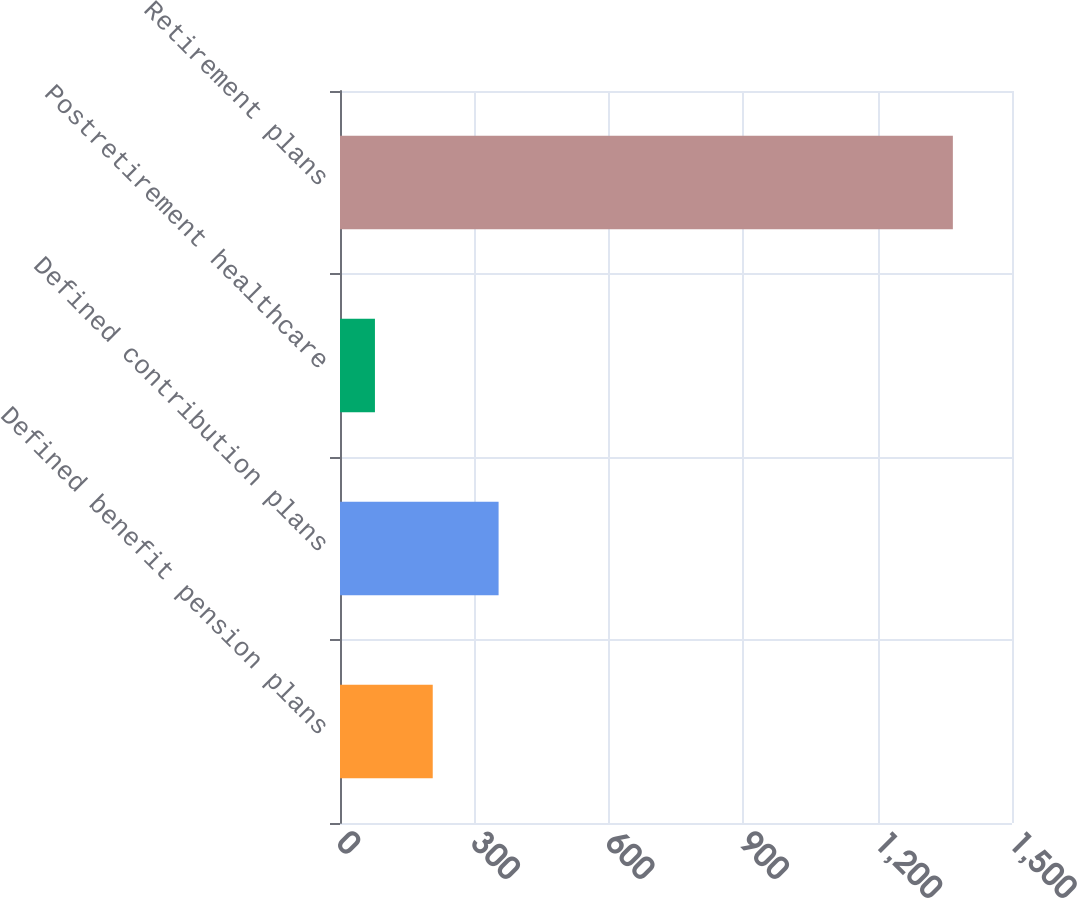Convert chart to OTSL. <chart><loc_0><loc_0><loc_500><loc_500><bar_chart><fcel>Defined benefit pension plans<fcel>Defined contribution plans<fcel>Postretirement healthcare<fcel>Retirement plans<nl><fcel>207<fcel>354<fcel>78<fcel>1368<nl></chart> 